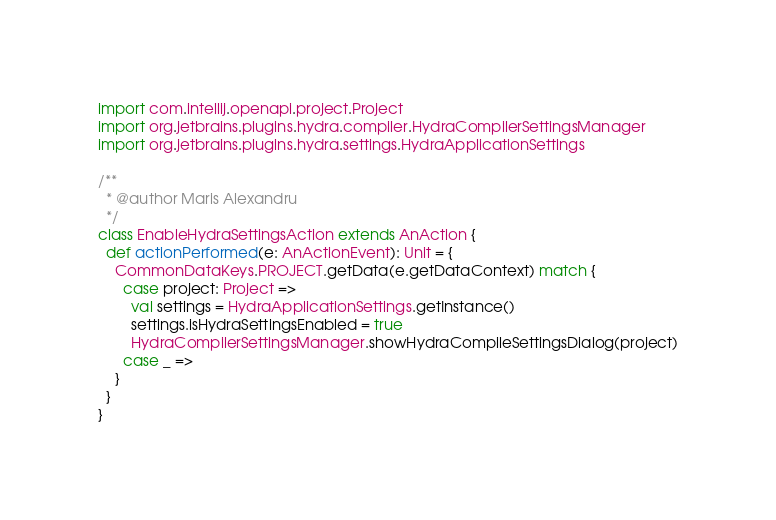<code> <loc_0><loc_0><loc_500><loc_500><_Scala_>import com.intellij.openapi.project.Project
import org.jetbrains.plugins.hydra.compiler.HydraCompilerSettingsManager
import org.jetbrains.plugins.hydra.settings.HydraApplicationSettings

/**
  * @author Maris Alexandru
  */
class EnableHydraSettingsAction extends AnAction {
  def actionPerformed(e: AnActionEvent): Unit = {
    CommonDataKeys.PROJECT.getData(e.getDataContext) match {
      case project: Project =>
        val settings = HydraApplicationSettings.getInstance()
        settings.isHydraSettingsEnabled = true
        HydraCompilerSettingsManager.showHydraCompileSettingsDialog(project)
      case _ =>
    }
  }
}
</code> 